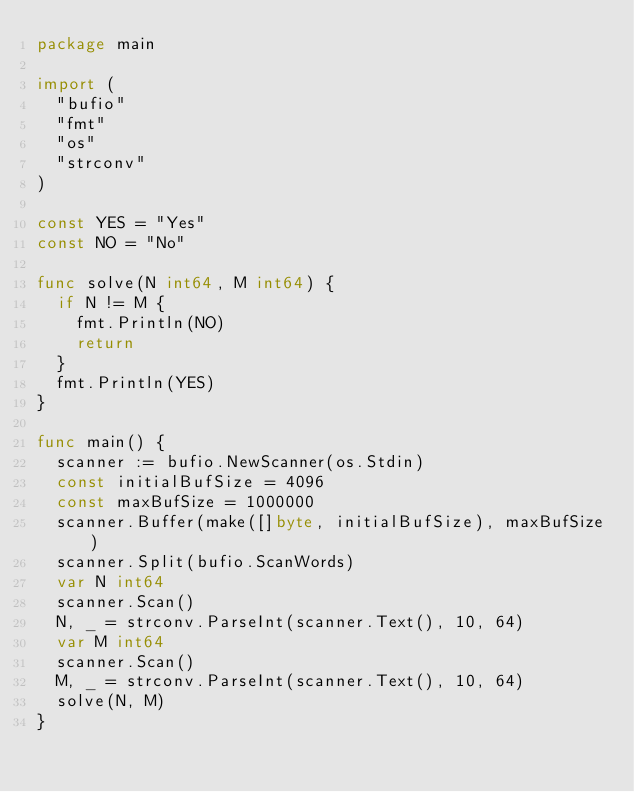<code> <loc_0><loc_0><loc_500><loc_500><_Go_>package main

import (
	"bufio"
	"fmt"
	"os"
	"strconv"
)

const YES = "Yes"
const NO = "No"

func solve(N int64, M int64) {
	if N != M {
		fmt.Println(NO)
		return
	}
	fmt.Println(YES)
}

func main() {
	scanner := bufio.NewScanner(os.Stdin)
	const initialBufSize = 4096
	const maxBufSize = 1000000
	scanner.Buffer(make([]byte, initialBufSize), maxBufSize)
	scanner.Split(bufio.ScanWords)
	var N int64
	scanner.Scan()
	N, _ = strconv.ParseInt(scanner.Text(), 10, 64)
	var M int64
	scanner.Scan()
	M, _ = strconv.ParseInt(scanner.Text(), 10, 64)
	solve(N, M)
}
</code> 